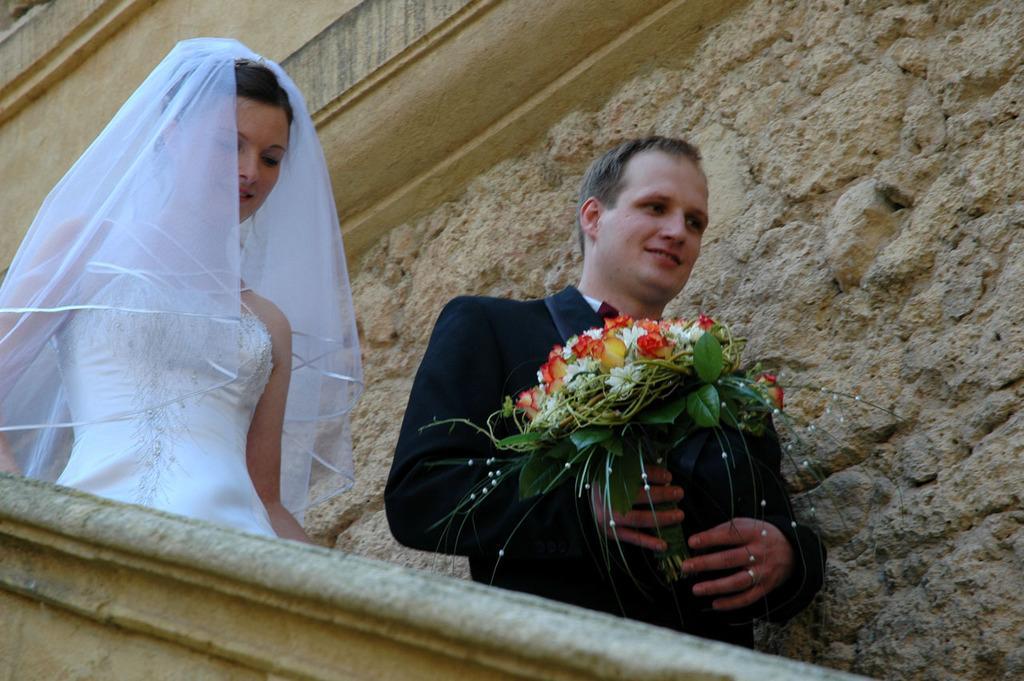How would you summarize this image in a sentence or two? This picture shows a man and women getting down the stairs and we see a building and man holding a flower vase in his hand and women wore white color dress with a cloth on her head and man wore a coat. 